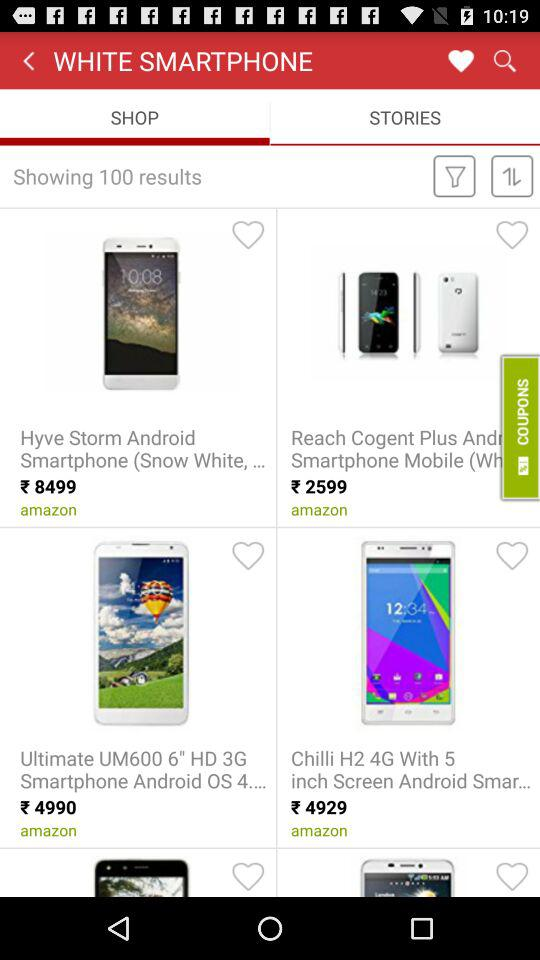How much of an inch screen does the Chilli H2 4G mobile have? The Chilli H2 4G mobile has a 5-inch screen. 